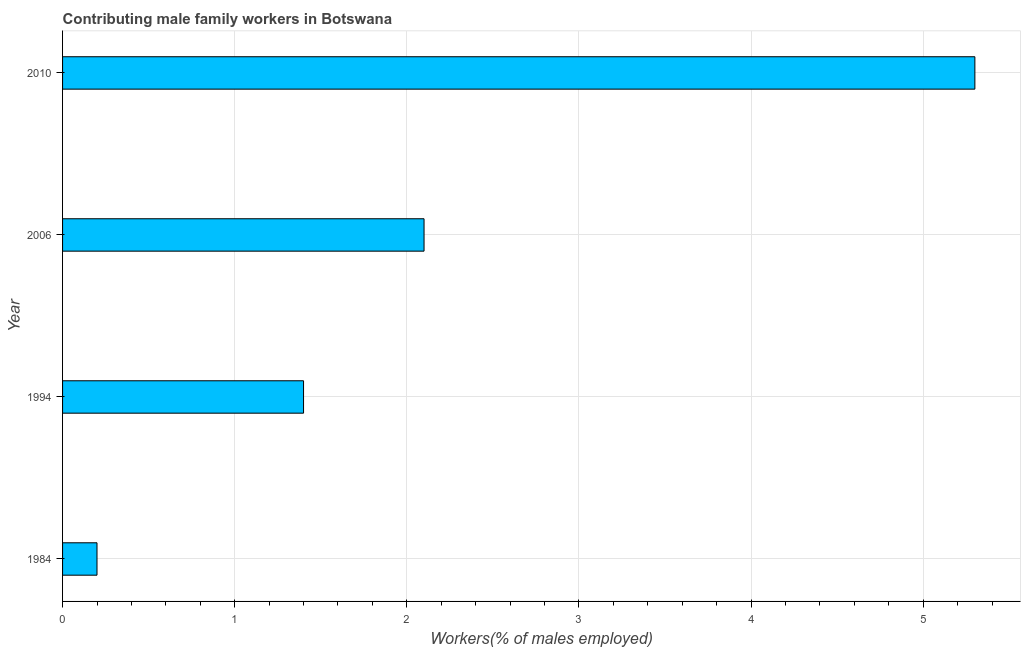Does the graph contain any zero values?
Offer a terse response. No. Does the graph contain grids?
Give a very brief answer. Yes. What is the title of the graph?
Provide a short and direct response. Contributing male family workers in Botswana. What is the label or title of the X-axis?
Provide a succinct answer. Workers(% of males employed). What is the contributing male family workers in 2010?
Make the answer very short. 5.3. Across all years, what is the maximum contributing male family workers?
Keep it short and to the point. 5.3. Across all years, what is the minimum contributing male family workers?
Your answer should be compact. 0.2. In which year was the contributing male family workers minimum?
Keep it short and to the point. 1984. What is the sum of the contributing male family workers?
Your answer should be compact. 9. What is the average contributing male family workers per year?
Make the answer very short. 2.25. What is the median contributing male family workers?
Offer a terse response. 1.75. What is the ratio of the contributing male family workers in 2006 to that in 2010?
Offer a terse response. 0.4. Is the difference between the contributing male family workers in 1984 and 1994 greater than the difference between any two years?
Provide a succinct answer. No. Is the sum of the contributing male family workers in 1994 and 2010 greater than the maximum contributing male family workers across all years?
Your response must be concise. Yes. How many bars are there?
Offer a very short reply. 4. Are all the bars in the graph horizontal?
Offer a very short reply. Yes. What is the difference between two consecutive major ticks on the X-axis?
Ensure brevity in your answer.  1. Are the values on the major ticks of X-axis written in scientific E-notation?
Provide a short and direct response. No. What is the Workers(% of males employed) in 1984?
Provide a short and direct response. 0.2. What is the Workers(% of males employed) of 1994?
Keep it short and to the point. 1.4. What is the Workers(% of males employed) of 2006?
Your response must be concise. 2.1. What is the Workers(% of males employed) of 2010?
Keep it short and to the point. 5.3. What is the difference between the Workers(% of males employed) in 1984 and 1994?
Ensure brevity in your answer.  -1.2. What is the difference between the Workers(% of males employed) in 1984 and 2006?
Ensure brevity in your answer.  -1.9. What is the difference between the Workers(% of males employed) in 1984 and 2010?
Ensure brevity in your answer.  -5.1. What is the difference between the Workers(% of males employed) in 1994 and 2010?
Keep it short and to the point. -3.9. What is the ratio of the Workers(% of males employed) in 1984 to that in 1994?
Your response must be concise. 0.14. What is the ratio of the Workers(% of males employed) in 1984 to that in 2006?
Make the answer very short. 0.1. What is the ratio of the Workers(% of males employed) in 1984 to that in 2010?
Your response must be concise. 0.04. What is the ratio of the Workers(% of males employed) in 1994 to that in 2006?
Provide a succinct answer. 0.67. What is the ratio of the Workers(% of males employed) in 1994 to that in 2010?
Give a very brief answer. 0.26. What is the ratio of the Workers(% of males employed) in 2006 to that in 2010?
Keep it short and to the point. 0.4. 